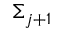Convert formula to latex. <formula><loc_0><loc_0><loc_500><loc_500>\Sigma _ { j + 1 }</formula> 